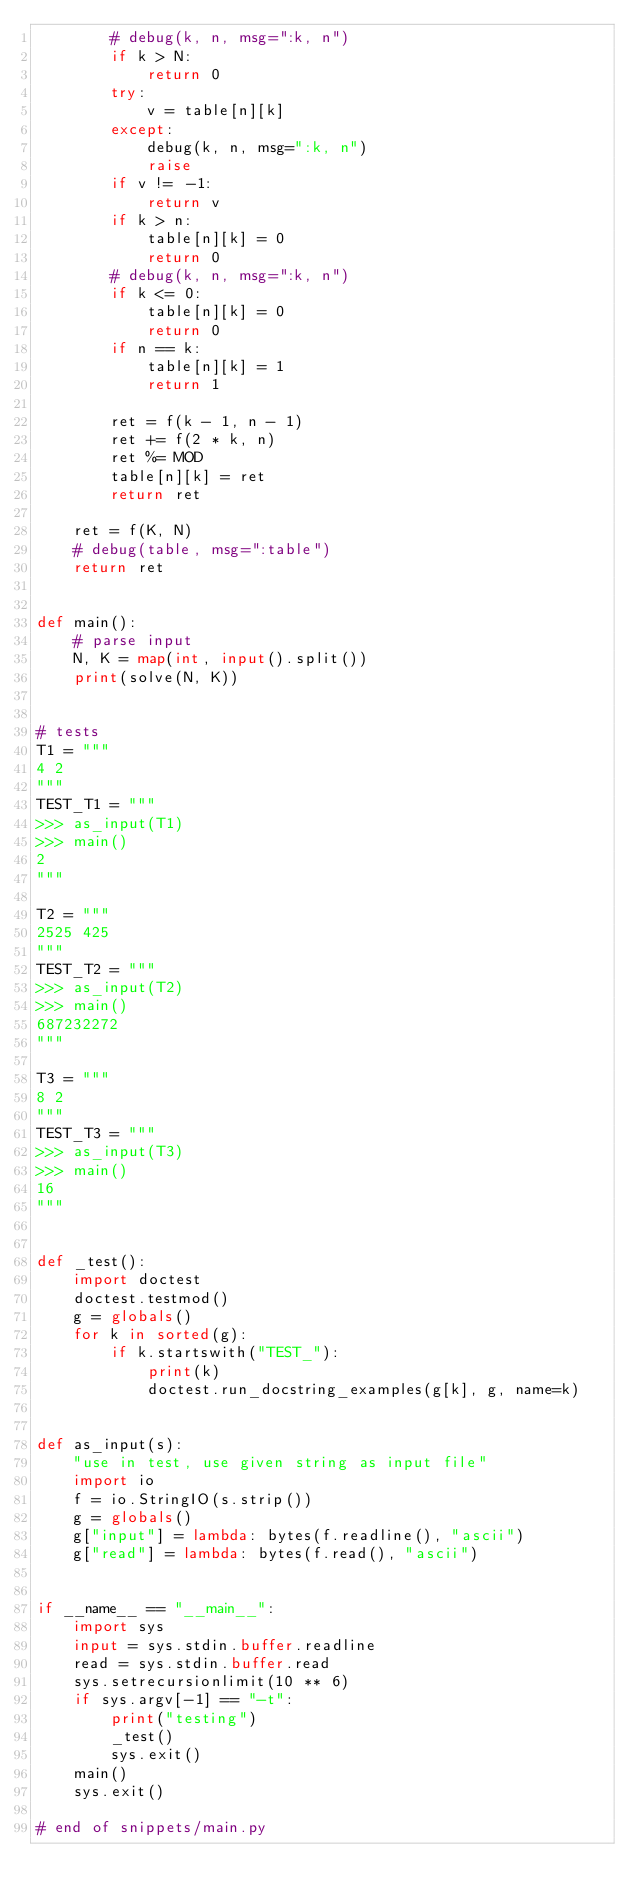Convert code to text. <code><loc_0><loc_0><loc_500><loc_500><_Python_>        # debug(k, n, msg=":k, n")
        if k > N:
            return 0
        try:
            v = table[n][k]
        except:
            debug(k, n, msg=":k, n")
            raise
        if v != -1:
            return v
        if k > n:
            table[n][k] = 0
            return 0
        # debug(k, n, msg=":k, n")
        if k <= 0:
            table[n][k] = 0
            return 0
        if n == k:
            table[n][k] = 1
            return 1

        ret = f(k - 1, n - 1)
        ret += f(2 * k, n)
        ret %= MOD
        table[n][k] = ret
        return ret

    ret = f(K, N)
    # debug(table, msg=":table")
    return ret


def main():
    # parse input
    N, K = map(int, input().split())
    print(solve(N, K))


# tests
T1 = """
4 2
"""
TEST_T1 = """
>>> as_input(T1)
>>> main()
2
"""

T2 = """
2525 425
"""
TEST_T2 = """
>>> as_input(T2)
>>> main()
687232272
"""

T3 = """
8 2
"""
TEST_T3 = """
>>> as_input(T3)
>>> main()
16
"""


def _test():
    import doctest
    doctest.testmod()
    g = globals()
    for k in sorted(g):
        if k.startswith("TEST_"):
            print(k)
            doctest.run_docstring_examples(g[k], g, name=k)


def as_input(s):
    "use in test, use given string as input file"
    import io
    f = io.StringIO(s.strip())
    g = globals()
    g["input"] = lambda: bytes(f.readline(), "ascii")
    g["read"] = lambda: bytes(f.read(), "ascii")


if __name__ == "__main__":
    import sys
    input = sys.stdin.buffer.readline
    read = sys.stdin.buffer.read
    sys.setrecursionlimit(10 ** 6)
    if sys.argv[-1] == "-t":
        print("testing")
        _test()
        sys.exit()
    main()
    sys.exit()

# end of snippets/main.py
</code> 